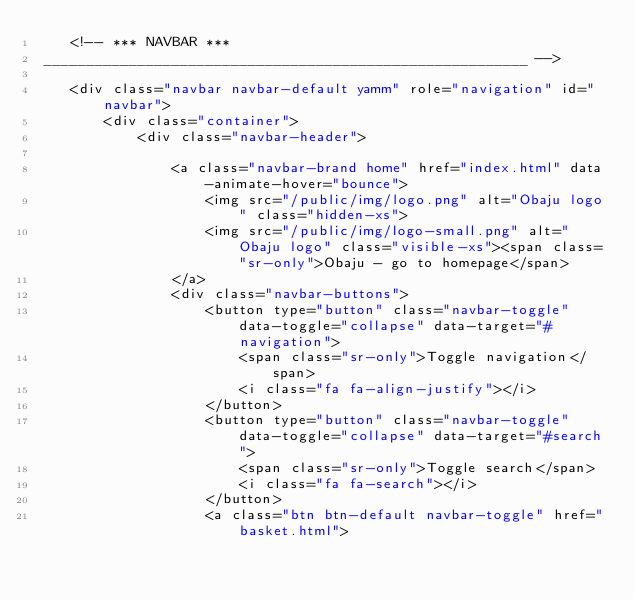Convert code to text. <code><loc_0><loc_0><loc_500><loc_500><_PHP_>    <!-- *** NAVBAR ***
 _________________________________________________________ -->

    <div class="navbar navbar-default yamm" role="navigation" id="navbar">
        <div class="container">
            <div class="navbar-header">

                <a class="navbar-brand home" href="index.html" data-animate-hover="bounce">
                    <img src="/public/img/logo.png" alt="Obaju logo" class="hidden-xs">
                    <img src="/public/img/logo-small.png" alt="Obaju logo" class="visible-xs"><span class="sr-only">Obaju - go to homepage</span>
                </a>
                <div class="navbar-buttons">
                    <button type="button" class="navbar-toggle" data-toggle="collapse" data-target="#navigation">
                        <span class="sr-only">Toggle navigation</span>
                        <i class="fa fa-align-justify"></i>
                    </button>
                    <button type="button" class="navbar-toggle" data-toggle="collapse" data-target="#search">
                        <span class="sr-only">Toggle search</span>
                        <i class="fa fa-search"></i>
                    </button>
                    <a class="btn btn-default navbar-toggle" href="basket.html"></code> 